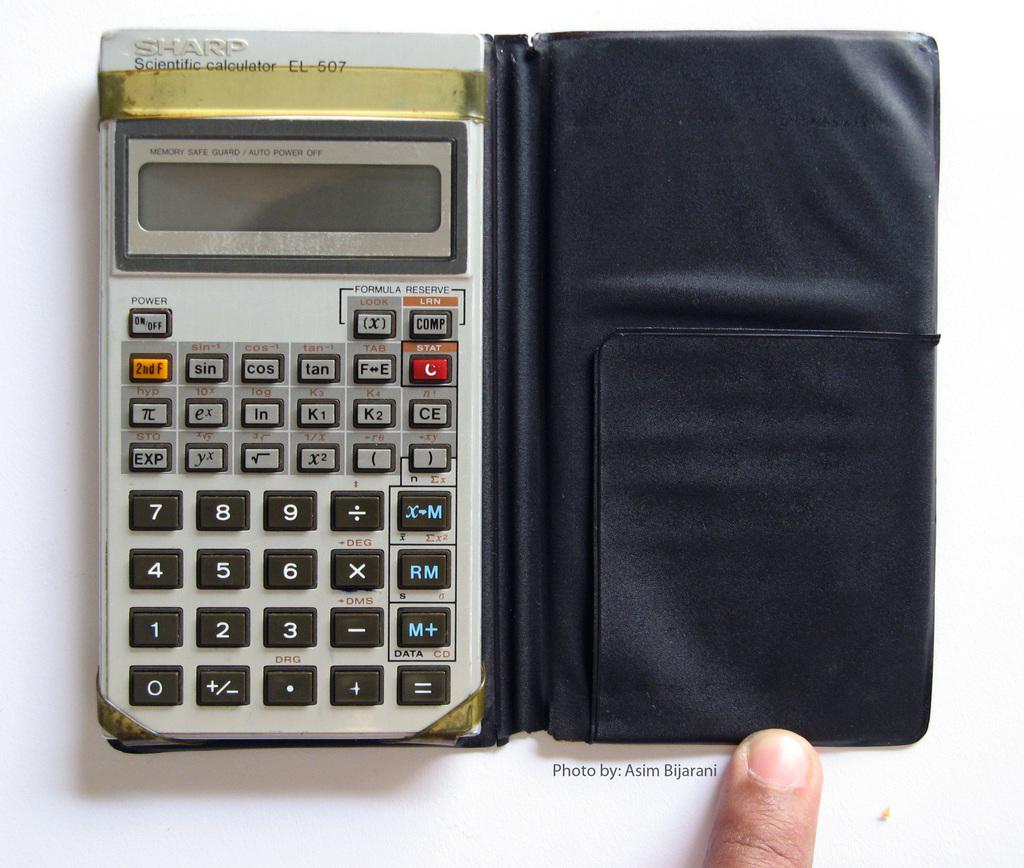What brand of calculator is this?
Your response must be concise. Sharp. What three numbers are directly above 0?
Provide a succinct answer. 1. 